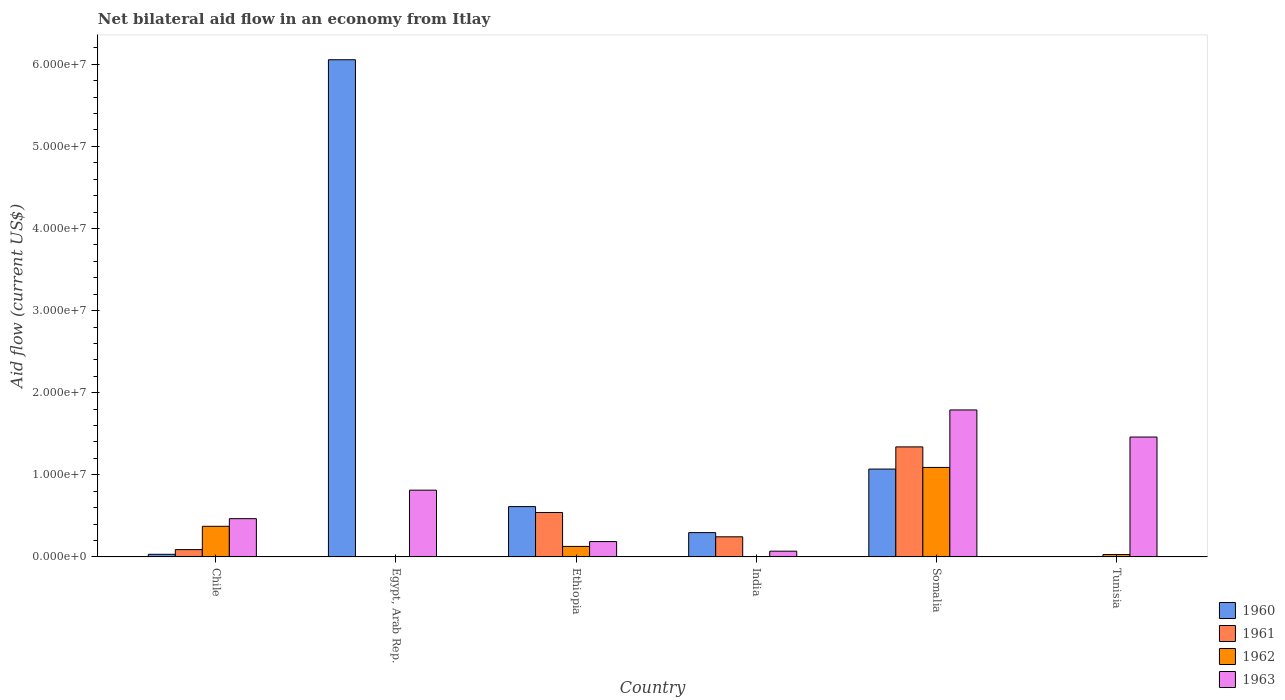How many different coloured bars are there?
Your response must be concise. 4. How many groups of bars are there?
Offer a terse response. 6. Are the number of bars per tick equal to the number of legend labels?
Your response must be concise. No. How many bars are there on the 3rd tick from the left?
Your response must be concise. 4. What is the label of the 2nd group of bars from the left?
Offer a very short reply. Egypt, Arab Rep. In how many cases, is the number of bars for a given country not equal to the number of legend labels?
Your response must be concise. 2. Across all countries, what is the maximum net bilateral aid flow in 1963?
Your answer should be very brief. 1.79e+07. In which country was the net bilateral aid flow in 1961 maximum?
Make the answer very short. Somalia. What is the total net bilateral aid flow in 1962 in the graph?
Provide a succinct answer. 1.62e+07. What is the difference between the net bilateral aid flow in 1960 in Ethiopia and that in India?
Offer a very short reply. 3.17e+06. What is the average net bilateral aid flow in 1963 per country?
Your answer should be very brief. 7.98e+06. What is the difference between the net bilateral aid flow of/in 1961 and net bilateral aid flow of/in 1962 in Somalia?
Provide a short and direct response. 2.50e+06. In how many countries, is the net bilateral aid flow in 1960 greater than 22000000 US$?
Give a very brief answer. 1. What is the ratio of the net bilateral aid flow in 1960 in Egypt, Arab Rep. to that in Ethiopia?
Make the answer very short. 9.88. Is the net bilateral aid flow in 1963 in Chile less than that in Somalia?
Give a very brief answer. Yes. What is the difference between the highest and the second highest net bilateral aid flow in 1963?
Provide a short and direct response. 3.30e+06. What is the difference between the highest and the lowest net bilateral aid flow in 1960?
Your answer should be very brief. 6.05e+07. In how many countries, is the net bilateral aid flow in 1960 greater than the average net bilateral aid flow in 1960 taken over all countries?
Keep it short and to the point. 1. Is the sum of the net bilateral aid flow in 1963 in India and Tunisia greater than the maximum net bilateral aid flow in 1960 across all countries?
Offer a terse response. No. Is it the case that in every country, the sum of the net bilateral aid flow in 1963 and net bilateral aid flow in 1962 is greater than the sum of net bilateral aid flow in 1960 and net bilateral aid flow in 1961?
Keep it short and to the point. No. Is it the case that in every country, the sum of the net bilateral aid flow in 1961 and net bilateral aid flow in 1963 is greater than the net bilateral aid flow in 1960?
Make the answer very short. No. How many bars are there?
Your answer should be compact. 21. What is the difference between two consecutive major ticks on the Y-axis?
Offer a terse response. 1.00e+07. Are the values on the major ticks of Y-axis written in scientific E-notation?
Provide a short and direct response. Yes. Does the graph contain grids?
Your response must be concise. No. How are the legend labels stacked?
Give a very brief answer. Vertical. What is the title of the graph?
Your answer should be compact. Net bilateral aid flow in an economy from Itlay. What is the label or title of the X-axis?
Make the answer very short. Country. What is the label or title of the Y-axis?
Your answer should be very brief. Aid flow (current US$). What is the Aid flow (current US$) in 1960 in Chile?
Offer a terse response. 3.20e+05. What is the Aid flow (current US$) in 1961 in Chile?
Your answer should be very brief. 8.90e+05. What is the Aid flow (current US$) of 1962 in Chile?
Provide a short and direct response. 3.73e+06. What is the Aid flow (current US$) in 1963 in Chile?
Provide a succinct answer. 4.66e+06. What is the Aid flow (current US$) in 1960 in Egypt, Arab Rep.?
Offer a terse response. 6.06e+07. What is the Aid flow (current US$) in 1962 in Egypt, Arab Rep.?
Your answer should be very brief. 0. What is the Aid flow (current US$) in 1963 in Egypt, Arab Rep.?
Give a very brief answer. 8.13e+06. What is the Aid flow (current US$) of 1960 in Ethiopia?
Provide a succinct answer. 6.13e+06. What is the Aid flow (current US$) in 1961 in Ethiopia?
Your answer should be compact. 5.41e+06. What is the Aid flow (current US$) in 1962 in Ethiopia?
Your response must be concise. 1.28e+06. What is the Aid flow (current US$) in 1963 in Ethiopia?
Give a very brief answer. 1.87e+06. What is the Aid flow (current US$) of 1960 in India?
Provide a short and direct response. 2.96e+06. What is the Aid flow (current US$) of 1961 in India?
Provide a short and direct response. 2.45e+06. What is the Aid flow (current US$) of 1962 in India?
Provide a short and direct response. 0. What is the Aid flow (current US$) in 1960 in Somalia?
Give a very brief answer. 1.07e+07. What is the Aid flow (current US$) in 1961 in Somalia?
Keep it short and to the point. 1.34e+07. What is the Aid flow (current US$) of 1962 in Somalia?
Offer a very short reply. 1.09e+07. What is the Aid flow (current US$) in 1963 in Somalia?
Give a very brief answer. 1.79e+07. What is the Aid flow (current US$) in 1960 in Tunisia?
Offer a terse response. 2.00e+04. What is the Aid flow (current US$) of 1961 in Tunisia?
Your response must be concise. 2.00e+04. What is the Aid flow (current US$) of 1963 in Tunisia?
Your answer should be compact. 1.46e+07. Across all countries, what is the maximum Aid flow (current US$) in 1960?
Offer a terse response. 6.06e+07. Across all countries, what is the maximum Aid flow (current US$) in 1961?
Keep it short and to the point. 1.34e+07. Across all countries, what is the maximum Aid flow (current US$) of 1962?
Your answer should be compact. 1.09e+07. Across all countries, what is the maximum Aid flow (current US$) of 1963?
Your answer should be very brief. 1.79e+07. Across all countries, what is the minimum Aid flow (current US$) in 1960?
Your answer should be compact. 2.00e+04. Across all countries, what is the minimum Aid flow (current US$) in 1962?
Make the answer very short. 0. Across all countries, what is the minimum Aid flow (current US$) in 1963?
Offer a terse response. 7.00e+05. What is the total Aid flow (current US$) in 1960 in the graph?
Your answer should be compact. 8.07e+07. What is the total Aid flow (current US$) in 1961 in the graph?
Make the answer very short. 2.22e+07. What is the total Aid flow (current US$) of 1962 in the graph?
Your response must be concise. 1.62e+07. What is the total Aid flow (current US$) of 1963 in the graph?
Offer a terse response. 4.79e+07. What is the difference between the Aid flow (current US$) in 1960 in Chile and that in Egypt, Arab Rep.?
Offer a terse response. -6.02e+07. What is the difference between the Aid flow (current US$) of 1963 in Chile and that in Egypt, Arab Rep.?
Ensure brevity in your answer.  -3.47e+06. What is the difference between the Aid flow (current US$) in 1960 in Chile and that in Ethiopia?
Provide a short and direct response. -5.81e+06. What is the difference between the Aid flow (current US$) in 1961 in Chile and that in Ethiopia?
Keep it short and to the point. -4.52e+06. What is the difference between the Aid flow (current US$) of 1962 in Chile and that in Ethiopia?
Offer a very short reply. 2.45e+06. What is the difference between the Aid flow (current US$) in 1963 in Chile and that in Ethiopia?
Provide a succinct answer. 2.79e+06. What is the difference between the Aid flow (current US$) of 1960 in Chile and that in India?
Offer a very short reply. -2.64e+06. What is the difference between the Aid flow (current US$) of 1961 in Chile and that in India?
Give a very brief answer. -1.56e+06. What is the difference between the Aid flow (current US$) in 1963 in Chile and that in India?
Offer a terse response. 3.96e+06. What is the difference between the Aid flow (current US$) in 1960 in Chile and that in Somalia?
Offer a very short reply. -1.04e+07. What is the difference between the Aid flow (current US$) of 1961 in Chile and that in Somalia?
Your answer should be compact. -1.25e+07. What is the difference between the Aid flow (current US$) in 1962 in Chile and that in Somalia?
Provide a succinct answer. -7.17e+06. What is the difference between the Aid flow (current US$) of 1963 in Chile and that in Somalia?
Provide a short and direct response. -1.32e+07. What is the difference between the Aid flow (current US$) of 1961 in Chile and that in Tunisia?
Ensure brevity in your answer.  8.70e+05. What is the difference between the Aid flow (current US$) of 1962 in Chile and that in Tunisia?
Offer a very short reply. 3.44e+06. What is the difference between the Aid flow (current US$) in 1963 in Chile and that in Tunisia?
Your answer should be compact. -9.94e+06. What is the difference between the Aid flow (current US$) in 1960 in Egypt, Arab Rep. and that in Ethiopia?
Offer a terse response. 5.44e+07. What is the difference between the Aid flow (current US$) in 1963 in Egypt, Arab Rep. and that in Ethiopia?
Offer a very short reply. 6.26e+06. What is the difference between the Aid flow (current US$) of 1960 in Egypt, Arab Rep. and that in India?
Your answer should be very brief. 5.76e+07. What is the difference between the Aid flow (current US$) in 1963 in Egypt, Arab Rep. and that in India?
Offer a very short reply. 7.43e+06. What is the difference between the Aid flow (current US$) of 1960 in Egypt, Arab Rep. and that in Somalia?
Ensure brevity in your answer.  4.98e+07. What is the difference between the Aid flow (current US$) in 1963 in Egypt, Arab Rep. and that in Somalia?
Provide a short and direct response. -9.77e+06. What is the difference between the Aid flow (current US$) in 1960 in Egypt, Arab Rep. and that in Tunisia?
Your answer should be compact. 6.05e+07. What is the difference between the Aid flow (current US$) of 1963 in Egypt, Arab Rep. and that in Tunisia?
Your answer should be compact. -6.47e+06. What is the difference between the Aid flow (current US$) in 1960 in Ethiopia and that in India?
Keep it short and to the point. 3.17e+06. What is the difference between the Aid flow (current US$) of 1961 in Ethiopia and that in India?
Your response must be concise. 2.96e+06. What is the difference between the Aid flow (current US$) in 1963 in Ethiopia and that in India?
Make the answer very short. 1.17e+06. What is the difference between the Aid flow (current US$) in 1960 in Ethiopia and that in Somalia?
Your answer should be very brief. -4.57e+06. What is the difference between the Aid flow (current US$) in 1961 in Ethiopia and that in Somalia?
Offer a very short reply. -7.99e+06. What is the difference between the Aid flow (current US$) of 1962 in Ethiopia and that in Somalia?
Your answer should be compact. -9.62e+06. What is the difference between the Aid flow (current US$) of 1963 in Ethiopia and that in Somalia?
Provide a short and direct response. -1.60e+07. What is the difference between the Aid flow (current US$) of 1960 in Ethiopia and that in Tunisia?
Offer a very short reply. 6.11e+06. What is the difference between the Aid flow (current US$) of 1961 in Ethiopia and that in Tunisia?
Make the answer very short. 5.39e+06. What is the difference between the Aid flow (current US$) in 1962 in Ethiopia and that in Tunisia?
Offer a very short reply. 9.90e+05. What is the difference between the Aid flow (current US$) of 1963 in Ethiopia and that in Tunisia?
Keep it short and to the point. -1.27e+07. What is the difference between the Aid flow (current US$) of 1960 in India and that in Somalia?
Offer a terse response. -7.74e+06. What is the difference between the Aid flow (current US$) of 1961 in India and that in Somalia?
Your answer should be very brief. -1.10e+07. What is the difference between the Aid flow (current US$) of 1963 in India and that in Somalia?
Your answer should be very brief. -1.72e+07. What is the difference between the Aid flow (current US$) in 1960 in India and that in Tunisia?
Offer a terse response. 2.94e+06. What is the difference between the Aid flow (current US$) in 1961 in India and that in Tunisia?
Your response must be concise. 2.43e+06. What is the difference between the Aid flow (current US$) in 1963 in India and that in Tunisia?
Your answer should be very brief. -1.39e+07. What is the difference between the Aid flow (current US$) in 1960 in Somalia and that in Tunisia?
Your answer should be compact. 1.07e+07. What is the difference between the Aid flow (current US$) of 1961 in Somalia and that in Tunisia?
Make the answer very short. 1.34e+07. What is the difference between the Aid flow (current US$) of 1962 in Somalia and that in Tunisia?
Ensure brevity in your answer.  1.06e+07. What is the difference between the Aid flow (current US$) of 1963 in Somalia and that in Tunisia?
Offer a very short reply. 3.30e+06. What is the difference between the Aid flow (current US$) of 1960 in Chile and the Aid flow (current US$) of 1963 in Egypt, Arab Rep.?
Offer a terse response. -7.81e+06. What is the difference between the Aid flow (current US$) of 1961 in Chile and the Aid flow (current US$) of 1963 in Egypt, Arab Rep.?
Give a very brief answer. -7.24e+06. What is the difference between the Aid flow (current US$) in 1962 in Chile and the Aid flow (current US$) in 1963 in Egypt, Arab Rep.?
Your response must be concise. -4.40e+06. What is the difference between the Aid flow (current US$) of 1960 in Chile and the Aid flow (current US$) of 1961 in Ethiopia?
Provide a succinct answer. -5.09e+06. What is the difference between the Aid flow (current US$) of 1960 in Chile and the Aid flow (current US$) of 1962 in Ethiopia?
Give a very brief answer. -9.60e+05. What is the difference between the Aid flow (current US$) in 1960 in Chile and the Aid flow (current US$) in 1963 in Ethiopia?
Your answer should be compact. -1.55e+06. What is the difference between the Aid flow (current US$) of 1961 in Chile and the Aid flow (current US$) of 1962 in Ethiopia?
Your answer should be compact. -3.90e+05. What is the difference between the Aid flow (current US$) in 1961 in Chile and the Aid flow (current US$) in 1963 in Ethiopia?
Keep it short and to the point. -9.80e+05. What is the difference between the Aid flow (current US$) of 1962 in Chile and the Aid flow (current US$) of 1963 in Ethiopia?
Keep it short and to the point. 1.86e+06. What is the difference between the Aid flow (current US$) in 1960 in Chile and the Aid flow (current US$) in 1961 in India?
Ensure brevity in your answer.  -2.13e+06. What is the difference between the Aid flow (current US$) in 1960 in Chile and the Aid flow (current US$) in 1963 in India?
Give a very brief answer. -3.80e+05. What is the difference between the Aid flow (current US$) of 1962 in Chile and the Aid flow (current US$) of 1963 in India?
Your answer should be compact. 3.03e+06. What is the difference between the Aid flow (current US$) of 1960 in Chile and the Aid flow (current US$) of 1961 in Somalia?
Ensure brevity in your answer.  -1.31e+07. What is the difference between the Aid flow (current US$) in 1960 in Chile and the Aid flow (current US$) in 1962 in Somalia?
Your answer should be very brief. -1.06e+07. What is the difference between the Aid flow (current US$) in 1960 in Chile and the Aid flow (current US$) in 1963 in Somalia?
Provide a short and direct response. -1.76e+07. What is the difference between the Aid flow (current US$) of 1961 in Chile and the Aid flow (current US$) of 1962 in Somalia?
Offer a terse response. -1.00e+07. What is the difference between the Aid flow (current US$) of 1961 in Chile and the Aid flow (current US$) of 1963 in Somalia?
Ensure brevity in your answer.  -1.70e+07. What is the difference between the Aid flow (current US$) of 1962 in Chile and the Aid flow (current US$) of 1963 in Somalia?
Make the answer very short. -1.42e+07. What is the difference between the Aid flow (current US$) in 1960 in Chile and the Aid flow (current US$) in 1963 in Tunisia?
Your answer should be very brief. -1.43e+07. What is the difference between the Aid flow (current US$) of 1961 in Chile and the Aid flow (current US$) of 1963 in Tunisia?
Offer a very short reply. -1.37e+07. What is the difference between the Aid flow (current US$) of 1962 in Chile and the Aid flow (current US$) of 1963 in Tunisia?
Your answer should be very brief. -1.09e+07. What is the difference between the Aid flow (current US$) in 1960 in Egypt, Arab Rep. and the Aid flow (current US$) in 1961 in Ethiopia?
Make the answer very short. 5.51e+07. What is the difference between the Aid flow (current US$) in 1960 in Egypt, Arab Rep. and the Aid flow (current US$) in 1962 in Ethiopia?
Your answer should be very brief. 5.93e+07. What is the difference between the Aid flow (current US$) in 1960 in Egypt, Arab Rep. and the Aid flow (current US$) in 1963 in Ethiopia?
Your answer should be compact. 5.87e+07. What is the difference between the Aid flow (current US$) in 1960 in Egypt, Arab Rep. and the Aid flow (current US$) in 1961 in India?
Give a very brief answer. 5.81e+07. What is the difference between the Aid flow (current US$) in 1960 in Egypt, Arab Rep. and the Aid flow (current US$) in 1963 in India?
Your answer should be very brief. 5.98e+07. What is the difference between the Aid flow (current US$) in 1960 in Egypt, Arab Rep. and the Aid flow (current US$) in 1961 in Somalia?
Provide a succinct answer. 4.72e+07. What is the difference between the Aid flow (current US$) of 1960 in Egypt, Arab Rep. and the Aid flow (current US$) of 1962 in Somalia?
Your response must be concise. 4.96e+07. What is the difference between the Aid flow (current US$) of 1960 in Egypt, Arab Rep. and the Aid flow (current US$) of 1963 in Somalia?
Give a very brief answer. 4.26e+07. What is the difference between the Aid flow (current US$) of 1960 in Egypt, Arab Rep. and the Aid flow (current US$) of 1961 in Tunisia?
Ensure brevity in your answer.  6.05e+07. What is the difference between the Aid flow (current US$) in 1960 in Egypt, Arab Rep. and the Aid flow (current US$) in 1962 in Tunisia?
Offer a very short reply. 6.03e+07. What is the difference between the Aid flow (current US$) of 1960 in Egypt, Arab Rep. and the Aid flow (current US$) of 1963 in Tunisia?
Your response must be concise. 4.60e+07. What is the difference between the Aid flow (current US$) in 1960 in Ethiopia and the Aid flow (current US$) in 1961 in India?
Ensure brevity in your answer.  3.68e+06. What is the difference between the Aid flow (current US$) in 1960 in Ethiopia and the Aid flow (current US$) in 1963 in India?
Ensure brevity in your answer.  5.43e+06. What is the difference between the Aid flow (current US$) of 1961 in Ethiopia and the Aid flow (current US$) of 1963 in India?
Your answer should be very brief. 4.71e+06. What is the difference between the Aid flow (current US$) of 1962 in Ethiopia and the Aid flow (current US$) of 1963 in India?
Your response must be concise. 5.80e+05. What is the difference between the Aid flow (current US$) in 1960 in Ethiopia and the Aid flow (current US$) in 1961 in Somalia?
Your response must be concise. -7.27e+06. What is the difference between the Aid flow (current US$) of 1960 in Ethiopia and the Aid flow (current US$) of 1962 in Somalia?
Ensure brevity in your answer.  -4.77e+06. What is the difference between the Aid flow (current US$) of 1960 in Ethiopia and the Aid flow (current US$) of 1963 in Somalia?
Offer a terse response. -1.18e+07. What is the difference between the Aid flow (current US$) in 1961 in Ethiopia and the Aid flow (current US$) in 1962 in Somalia?
Your answer should be very brief. -5.49e+06. What is the difference between the Aid flow (current US$) of 1961 in Ethiopia and the Aid flow (current US$) of 1963 in Somalia?
Keep it short and to the point. -1.25e+07. What is the difference between the Aid flow (current US$) of 1962 in Ethiopia and the Aid flow (current US$) of 1963 in Somalia?
Your answer should be compact. -1.66e+07. What is the difference between the Aid flow (current US$) in 1960 in Ethiopia and the Aid flow (current US$) in 1961 in Tunisia?
Keep it short and to the point. 6.11e+06. What is the difference between the Aid flow (current US$) of 1960 in Ethiopia and the Aid flow (current US$) of 1962 in Tunisia?
Make the answer very short. 5.84e+06. What is the difference between the Aid flow (current US$) in 1960 in Ethiopia and the Aid flow (current US$) in 1963 in Tunisia?
Your answer should be very brief. -8.47e+06. What is the difference between the Aid flow (current US$) of 1961 in Ethiopia and the Aid flow (current US$) of 1962 in Tunisia?
Ensure brevity in your answer.  5.12e+06. What is the difference between the Aid flow (current US$) in 1961 in Ethiopia and the Aid flow (current US$) in 1963 in Tunisia?
Provide a short and direct response. -9.19e+06. What is the difference between the Aid flow (current US$) in 1962 in Ethiopia and the Aid flow (current US$) in 1963 in Tunisia?
Provide a succinct answer. -1.33e+07. What is the difference between the Aid flow (current US$) in 1960 in India and the Aid flow (current US$) in 1961 in Somalia?
Make the answer very short. -1.04e+07. What is the difference between the Aid flow (current US$) in 1960 in India and the Aid flow (current US$) in 1962 in Somalia?
Your answer should be very brief. -7.94e+06. What is the difference between the Aid flow (current US$) in 1960 in India and the Aid flow (current US$) in 1963 in Somalia?
Your response must be concise. -1.49e+07. What is the difference between the Aid flow (current US$) in 1961 in India and the Aid flow (current US$) in 1962 in Somalia?
Provide a short and direct response. -8.45e+06. What is the difference between the Aid flow (current US$) of 1961 in India and the Aid flow (current US$) of 1963 in Somalia?
Your answer should be very brief. -1.54e+07. What is the difference between the Aid flow (current US$) in 1960 in India and the Aid flow (current US$) in 1961 in Tunisia?
Give a very brief answer. 2.94e+06. What is the difference between the Aid flow (current US$) of 1960 in India and the Aid flow (current US$) of 1962 in Tunisia?
Your answer should be compact. 2.67e+06. What is the difference between the Aid flow (current US$) of 1960 in India and the Aid flow (current US$) of 1963 in Tunisia?
Your answer should be compact. -1.16e+07. What is the difference between the Aid flow (current US$) in 1961 in India and the Aid flow (current US$) in 1962 in Tunisia?
Make the answer very short. 2.16e+06. What is the difference between the Aid flow (current US$) in 1961 in India and the Aid flow (current US$) in 1963 in Tunisia?
Ensure brevity in your answer.  -1.22e+07. What is the difference between the Aid flow (current US$) of 1960 in Somalia and the Aid flow (current US$) of 1961 in Tunisia?
Your answer should be very brief. 1.07e+07. What is the difference between the Aid flow (current US$) of 1960 in Somalia and the Aid flow (current US$) of 1962 in Tunisia?
Make the answer very short. 1.04e+07. What is the difference between the Aid flow (current US$) of 1960 in Somalia and the Aid flow (current US$) of 1963 in Tunisia?
Provide a short and direct response. -3.90e+06. What is the difference between the Aid flow (current US$) of 1961 in Somalia and the Aid flow (current US$) of 1962 in Tunisia?
Provide a short and direct response. 1.31e+07. What is the difference between the Aid flow (current US$) in 1961 in Somalia and the Aid flow (current US$) in 1963 in Tunisia?
Provide a short and direct response. -1.20e+06. What is the difference between the Aid flow (current US$) in 1962 in Somalia and the Aid flow (current US$) in 1963 in Tunisia?
Offer a terse response. -3.70e+06. What is the average Aid flow (current US$) in 1960 per country?
Ensure brevity in your answer.  1.34e+07. What is the average Aid flow (current US$) in 1961 per country?
Your response must be concise. 3.70e+06. What is the average Aid flow (current US$) in 1962 per country?
Offer a terse response. 2.70e+06. What is the average Aid flow (current US$) of 1963 per country?
Offer a terse response. 7.98e+06. What is the difference between the Aid flow (current US$) of 1960 and Aid flow (current US$) of 1961 in Chile?
Make the answer very short. -5.70e+05. What is the difference between the Aid flow (current US$) in 1960 and Aid flow (current US$) in 1962 in Chile?
Provide a succinct answer. -3.41e+06. What is the difference between the Aid flow (current US$) in 1960 and Aid flow (current US$) in 1963 in Chile?
Give a very brief answer. -4.34e+06. What is the difference between the Aid flow (current US$) of 1961 and Aid flow (current US$) of 1962 in Chile?
Your answer should be compact. -2.84e+06. What is the difference between the Aid flow (current US$) in 1961 and Aid flow (current US$) in 1963 in Chile?
Provide a short and direct response. -3.77e+06. What is the difference between the Aid flow (current US$) of 1962 and Aid flow (current US$) of 1963 in Chile?
Keep it short and to the point. -9.30e+05. What is the difference between the Aid flow (current US$) in 1960 and Aid flow (current US$) in 1963 in Egypt, Arab Rep.?
Ensure brevity in your answer.  5.24e+07. What is the difference between the Aid flow (current US$) of 1960 and Aid flow (current US$) of 1961 in Ethiopia?
Keep it short and to the point. 7.20e+05. What is the difference between the Aid flow (current US$) of 1960 and Aid flow (current US$) of 1962 in Ethiopia?
Provide a succinct answer. 4.85e+06. What is the difference between the Aid flow (current US$) of 1960 and Aid flow (current US$) of 1963 in Ethiopia?
Offer a terse response. 4.26e+06. What is the difference between the Aid flow (current US$) in 1961 and Aid flow (current US$) in 1962 in Ethiopia?
Offer a very short reply. 4.13e+06. What is the difference between the Aid flow (current US$) in 1961 and Aid flow (current US$) in 1963 in Ethiopia?
Give a very brief answer. 3.54e+06. What is the difference between the Aid flow (current US$) in 1962 and Aid flow (current US$) in 1963 in Ethiopia?
Give a very brief answer. -5.90e+05. What is the difference between the Aid flow (current US$) of 1960 and Aid flow (current US$) of 1961 in India?
Your response must be concise. 5.10e+05. What is the difference between the Aid flow (current US$) of 1960 and Aid flow (current US$) of 1963 in India?
Give a very brief answer. 2.26e+06. What is the difference between the Aid flow (current US$) in 1961 and Aid flow (current US$) in 1963 in India?
Provide a short and direct response. 1.75e+06. What is the difference between the Aid flow (current US$) in 1960 and Aid flow (current US$) in 1961 in Somalia?
Offer a terse response. -2.70e+06. What is the difference between the Aid flow (current US$) in 1960 and Aid flow (current US$) in 1963 in Somalia?
Ensure brevity in your answer.  -7.20e+06. What is the difference between the Aid flow (current US$) in 1961 and Aid flow (current US$) in 1962 in Somalia?
Make the answer very short. 2.50e+06. What is the difference between the Aid flow (current US$) in 1961 and Aid flow (current US$) in 1963 in Somalia?
Offer a very short reply. -4.50e+06. What is the difference between the Aid flow (current US$) in 1962 and Aid flow (current US$) in 1963 in Somalia?
Offer a very short reply. -7.00e+06. What is the difference between the Aid flow (current US$) of 1960 and Aid flow (current US$) of 1962 in Tunisia?
Ensure brevity in your answer.  -2.70e+05. What is the difference between the Aid flow (current US$) of 1960 and Aid flow (current US$) of 1963 in Tunisia?
Offer a terse response. -1.46e+07. What is the difference between the Aid flow (current US$) of 1961 and Aid flow (current US$) of 1962 in Tunisia?
Make the answer very short. -2.70e+05. What is the difference between the Aid flow (current US$) of 1961 and Aid flow (current US$) of 1963 in Tunisia?
Give a very brief answer. -1.46e+07. What is the difference between the Aid flow (current US$) of 1962 and Aid flow (current US$) of 1963 in Tunisia?
Give a very brief answer. -1.43e+07. What is the ratio of the Aid flow (current US$) of 1960 in Chile to that in Egypt, Arab Rep.?
Provide a short and direct response. 0.01. What is the ratio of the Aid flow (current US$) in 1963 in Chile to that in Egypt, Arab Rep.?
Give a very brief answer. 0.57. What is the ratio of the Aid flow (current US$) in 1960 in Chile to that in Ethiopia?
Offer a very short reply. 0.05. What is the ratio of the Aid flow (current US$) of 1961 in Chile to that in Ethiopia?
Offer a very short reply. 0.16. What is the ratio of the Aid flow (current US$) in 1962 in Chile to that in Ethiopia?
Provide a short and direct response. 2.91. What is the ratio of the Aid flow (current US$) of 1963 in Chile to that in Ethiopia?
Offer a very short reply. 2.49. What is the ratio of the Aid flow (current US$) of 1960 in Chile to that in India?
Make the answer very short. 0.11. What is the ratio of the Aid flow (current US$) of 1961 in Chile to that in India?
Your answer should be very brief. 0.36. What is the ratio of the Aid flow (current US$) of 1963 in Chile to that in India?
Provide a succinct answer. 6.66. What is the ratio of the Aid flow (current US$) of 1960 in Chile to that in Somalia?
Offer a very short reply. 0.03. What is the ratio of the Aid flow (current US$) in 1961 in Chile to that in Somalia?
Offer a very short reply. 0.07. What is the ratio of the Aid flow (current US$) of 1962 in Chile to that in Somalia?
Provide a short and direct response. 0.34. What is the ratio of the Aid flow (current US$) in 1963 in Chile to that in Somalia?
Give a very brief answer. 0.26. What is the ratio of the Aid flow (current US$) in 1960 in Chile to that in Tunisia?
Provide a short and direct response. 16. What is the ratio of the Aid flow (current US$) of 1961 in Chile to that in Tunisia?
Offer a terse response. 44.5. What is the ratio of the Aid flow (current US$) in 1962 in Chile to that in Tunisia?
Your response must be concise. 12.86. What is the ratio of the Aid flow (current US$) in 1963 in Chile to that in Tunisia?
Ensure brevity in your answer.  0.32. What is the ratio of the Aid flow (current US$) of 1960 in Egypt, Arab Rep. to that in Ethiopia?
Give a very brief answer. 9.88. What is the ratio of the Aid flow (current US$) of 1963 in Egypt, Arab Rep. to that in Ethiopia?
Provide a short and direct response. 4.35. What is the ratio of the Aid flow (current US$) of 1960 in Egypt, Arab Rep. to that in India?
Make the answer very short. 20.46. What is the ratio of the Aid flow (current US$) of 1963 in Egypt, Arab Rep. to that in India?
Provide a succinct answer. 11.61. What is the ratio of the Aid flow (current US$) in 1960 in Egypt, Arab Rep. to that in Somalia?
Offer a very short reply. 5.66. What is the ratio of the Aid flow (current US$) in 1963 in Egypt, Arab Rep. to that in Somalia?
Your answer should be compact. 0.45. What is the ratio of the Aid flow (current US$) in 1960 in Egypt, Arab Rep. to that in Tunisia?
Your answer should be very brief. 3027.5. What is the ratio of the Aid flow (current US$) of 1963 in Egypt, Arab Rep. to that in Tunisia?
Your response must be concise. 0.56. What is the ratio of the Aid flow (current US$) of 1960 in Ethiopia to that in India?
Offer a very short reply. 2.07. What is the ratio of the Aid flow (current US$) of 1961 in Ethiopia to that in India?
Give a very brief answer. 2.21. What is the ratio of the Aid flow (current US$) in 1963 in Ethiopia to that in India?
Make the answer very short. 2.67. What is the ratio of the Aid flow (current US$) in 1960 in Ethiopia to that in Somalia?
Your answer should be compact. 0.57. What is the ratio of the Aid flow (current US$) in 1961 in Ethiopia to that in Somalia?
Your answer should be very brief. 0.4. What is the ratio of the Aid flow (current US$) of 1962 in Ethiopia to that in Somalia?
Your answer should be very brief. 0.12. What is the ratio of the Aid flow (current US$) in 1963 in Ethiopia to that in Somalia?
Make the answer very short. 0.1. What is the ratio of the Aid flow (current US$) in 1960 in Ethiopia to that in Tunisia?
Provide a short and direct response. 306.5. What is the ratio of the Aid flow (current US$) in 1961 in Ethiopia to that in Tunisia?
Your answer should be compact. 270.5. What is the ratio of the Aid flow (current US$) in 1962 in Ethiopia to that in Tunisia?
Your response must be concise. 4.41. What is the ratio of the Aid flow (current US$) in 1963 in Ethiopia to that in Tunisia?
Your answer should be compact. 0.13. What is the ratio of the Aid flow (current US$) of 1960 in India to that in Somalia?
Provide a short and direct response. 0.28. What is the ratio of the Aid flow (current US$) in 1961 in India to that in Somalia?
Ensure brevity in your answer.  0.18. What is the ratio of the Aid flow (current US$) in 1963 in India to that in Somalia?
Your answer should be compact. 0.04. What is the ratio of the Aid flow (current US$) of 1960 in India to that in Tunisia?
Ensure brevity in your answer.  148. What is the ratio of the Aid flow (current US$) in 1961 in India to that in Tunisia?
Ensure brevity in your answer.  122.5. What is the ratio of the Aid flow (current US$) in 1963 in India to that in Tunisia?
Offer a terse response. 0.05. What is the ratio of the Aid flow (current US$) of 1960 in Somalia to that in Tunisia?
Your answer should be very brief. 535. What is the ratio of the Aid flow (current US$) in 1961 in Somalia to that in Tunisia?
Your answer should be compact. 670. What is the ratio of the Aid flow (current US$) in 1962 in Somalia to that in Tunisia?
Provide a short and direct response. 37.59. What is the ratio of the Aid flow (current US$) in 1963 in Somalia to that in Tunisia?
Offer a terse response. 1.23. What is the difference between the highest and the second highest Aid flow (current US$) in 1960?
Your response must be concise. 4.98e+07. What is the difference between the highest and the second highest Aid flow (current US$) of 1961?
Keep it short and to the point. 7.99e+06. What is the difference between the highest and the second highest Aid flow (current US$) in 1962?
Your answer should be very brief. 7.17e+06. What is the difference between the highest and the second highest Aid flow (current US$) of 1963?
Provide a short and direct response. 3.30e+06. What is the difference between the highest and the lowest Aid flow (current US$) in 1960?
Keep it short and to the point. 6.05e+07. What is the difference between the highest and the lowest Aid flow (current US$) in 1961?
Your answer should be compact. 1.34e+07. What is the difference between the highest and the lowest Aid flow (current US$) in 1962?
Provide a succinct answer. 1.09e+07. What is the difference between the highest and the lowest Aid flow (current US$) of 1963?
Provide a succinct answer. 1.72e+07. 